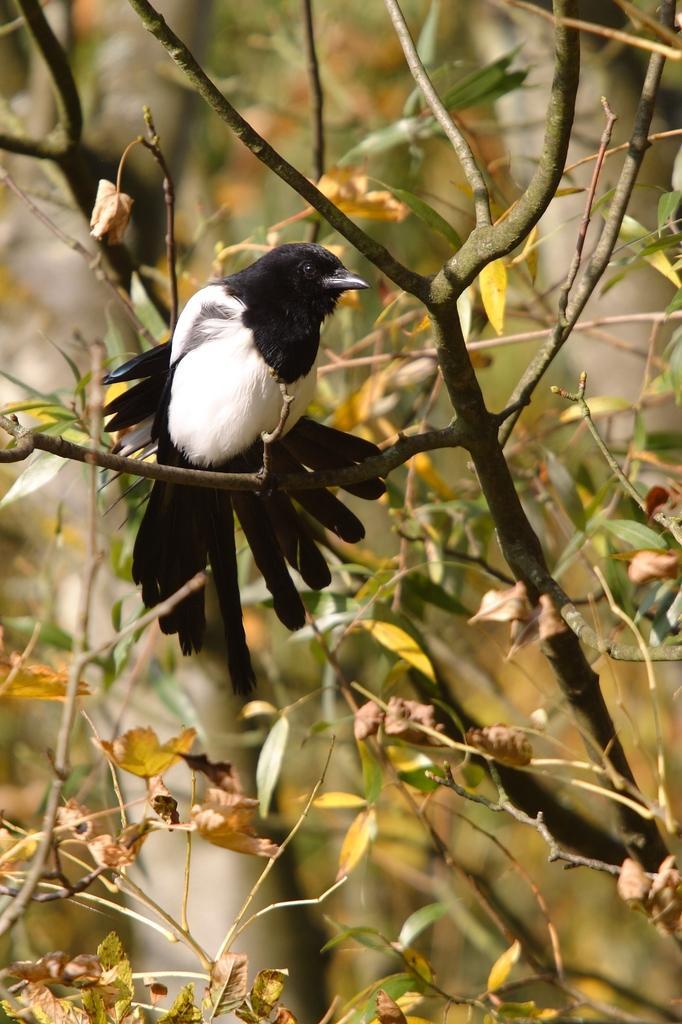Could you give a brief overview of what you see in this image? In the image there are branches with leaves and also there is a bird. And there is a blur background. 